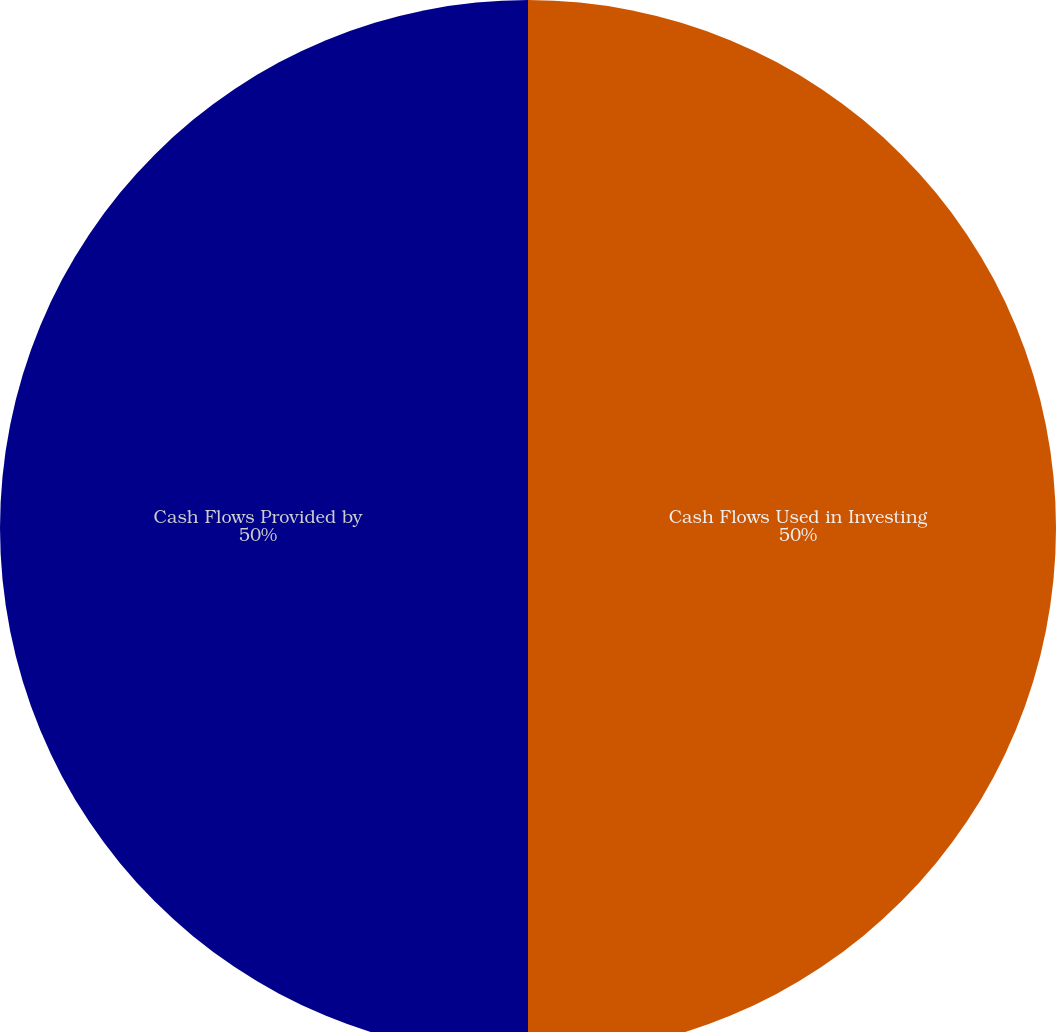Convert chart. <chart><loc_0><loc_0><loc_500><loc_500><pie_chart><fcel>Cash Flows Used in Investing<fcel>Cash Flows Provided by<nl><fcel>50.0%<fcel>50.0%<nl></chart> 